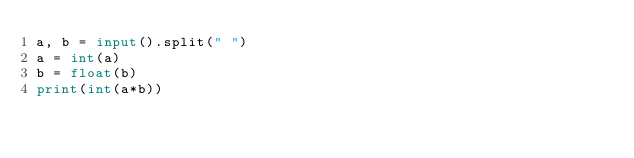Convert code to text. <code><loc_0><loc_0><loc_500><loc_500><_Python_>a, b = input().split(" ")
a = int(a)
b = float(b)
print(int(a*b))</code> 